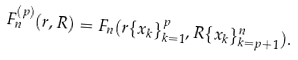Convert formula to latex. <formula><loc_0><loc_0><loc_500><loc_500>F _ { n } ^ { ( p ) } ( r , R ) = F _ { n } ( r \{ x _ { k } \} _ { k = 1 } ^ { p } , R \{ x _ { k } \} _ { k = p + 1 } ^ { n } ) .</formula> 